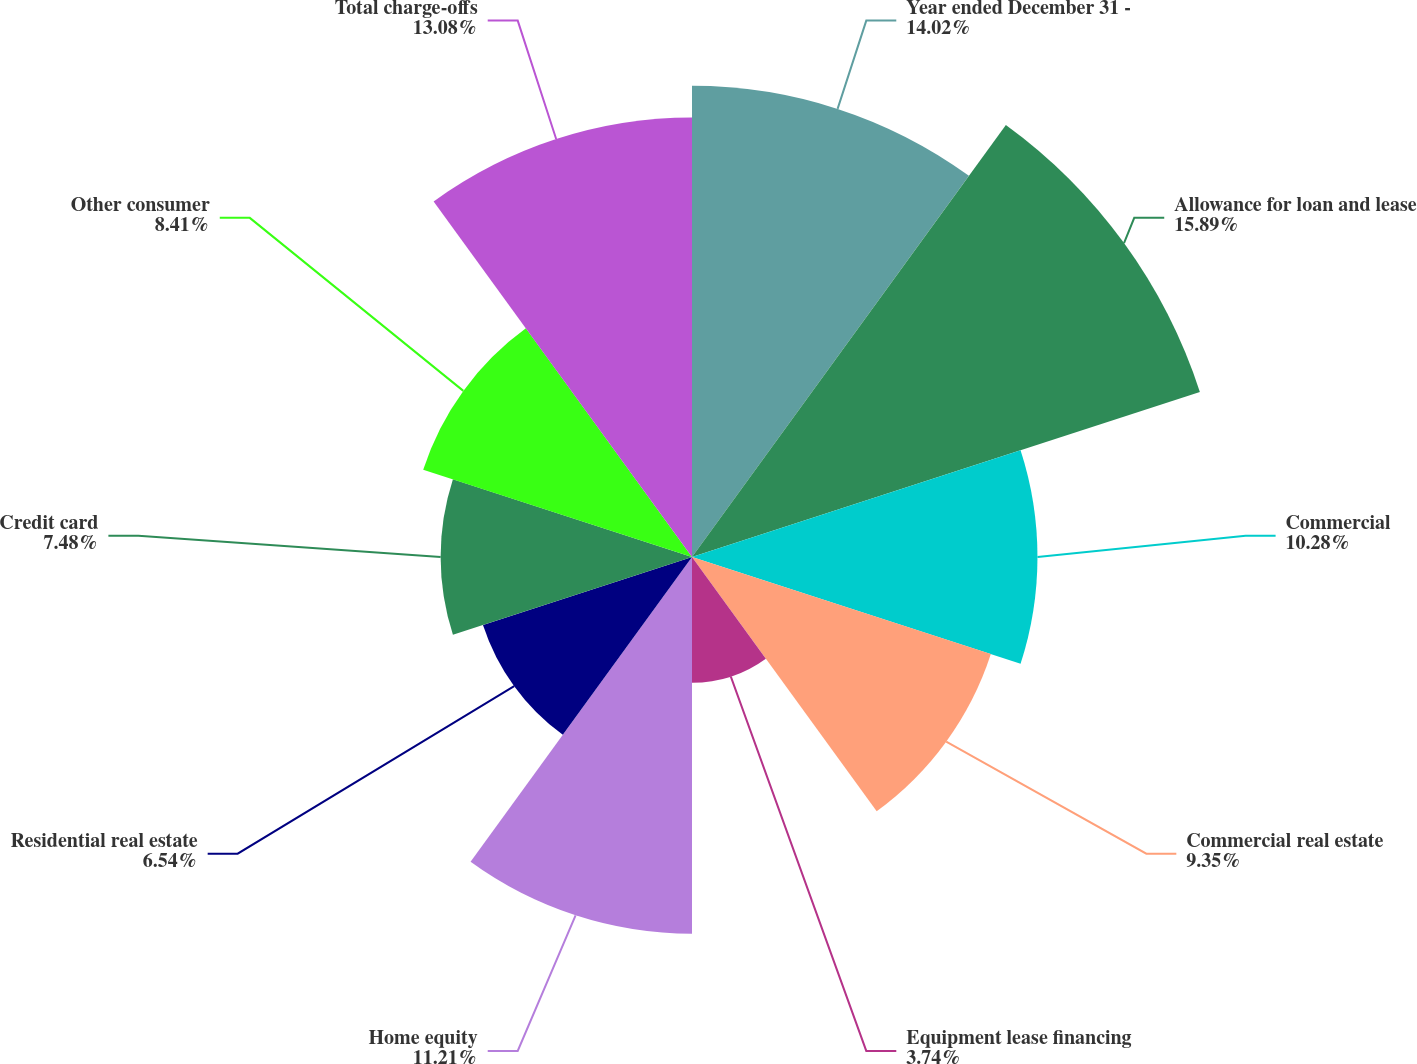Convert chart to OTSL. <chart><loc_0><loc_0><loc_500><loc_500><pie_chart><fcel>Year ended December 31 -<fcel>Allowance for loan and lease<fcel>Commercial<fcel>Commercial real estate<fcel>Equipment lease financing<fcel>Home equity<fcel>Residential real estate<fcel>Credit card<fcel>Other consumer<fcel>Total charge-offs<nl><fcel>14.02%<fcel>15.89%<fcel>10.28%<fcel>9.35%<fcel>3.74%<fcel>11.21%<fcel>6.54%<fcel>7.48%<fcel>8.41%<fcel>13.08%<nl></chart> 